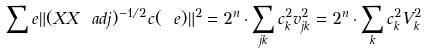<formula> <loc_0><loc_0><loc_500><loc_500>\sum _ { \ } e \| ( X X \ a d j ) ^ { - 1 / 2 } c ( \ e ) \| ^ { 2 } = 2 ^ { n } \cdot \sum _ { j k } c _ { k } ^ { 2 } v _ { j k } ^ { 2 } = 2 ^ { n } \cdot \sum _ { k } c _ { k } ^ { 2 } V _ { k } ^ { 2 }</formula> 